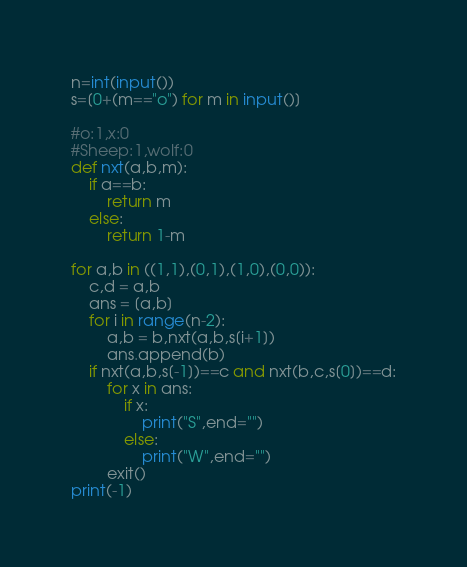Convert code to text. <code><loc_0><loc_0><loc_500><loc_500><_Python_>n=int(input())
s=[0+(m=="o") for m in input()]

#o:1,x:0
#Sheep:1,wolf:0
def nxt(a,b,m):
	if a==b:
		return m
	else:
		return 1-m

for a,b in ((1,1),(0,1),(1,0),(0,0)):
	c,d = a,b
	ans = [a,b]
	for i in range(n-2):
		a,b = b,nxt(a,b,s[i+1])
		ans.append(b)
	if nxt(a,b,s[-1])==c and nxt(b,c,s[0])==d:
		for x in ans:
			if x:
				print("S",end="")
			else:
				print("W",end="")
		exit()
print(-1)</code> 